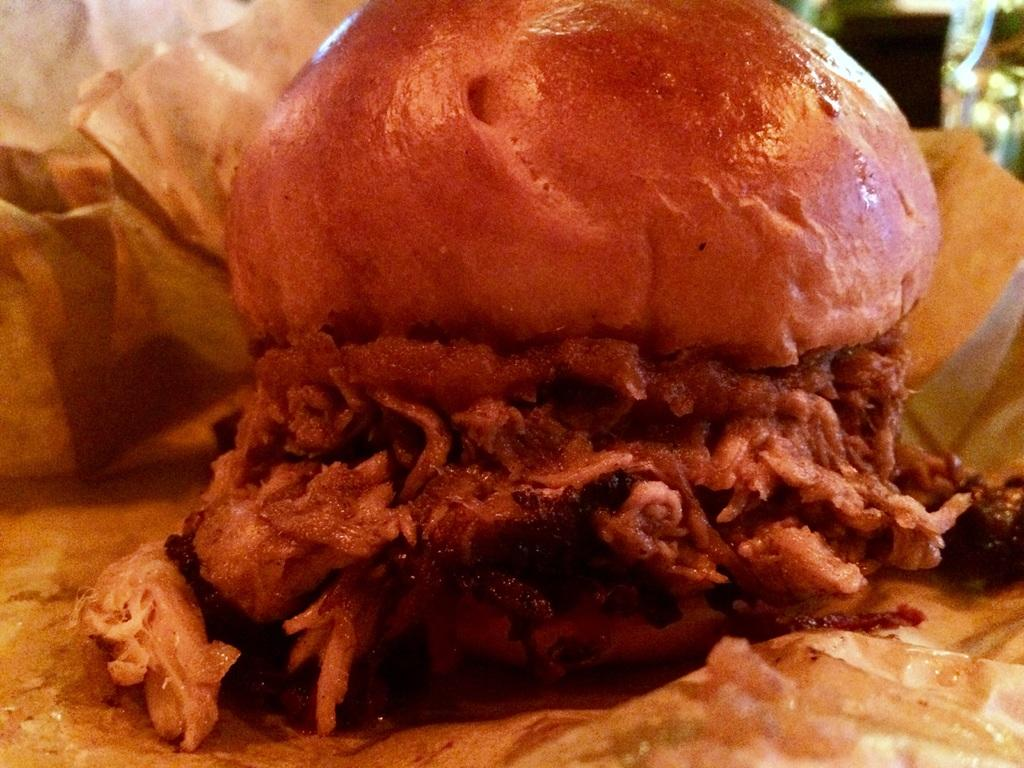What is the main subject of the image? The main subject of the image is food. Where is the food located in the image? The food is located in the middle of the image. What type of guitar can be seen in the image? There is no guitar present in the image; it only features food. Can you tell me how many straws are visible in the image? There is no straw present in the image; it only features food. 